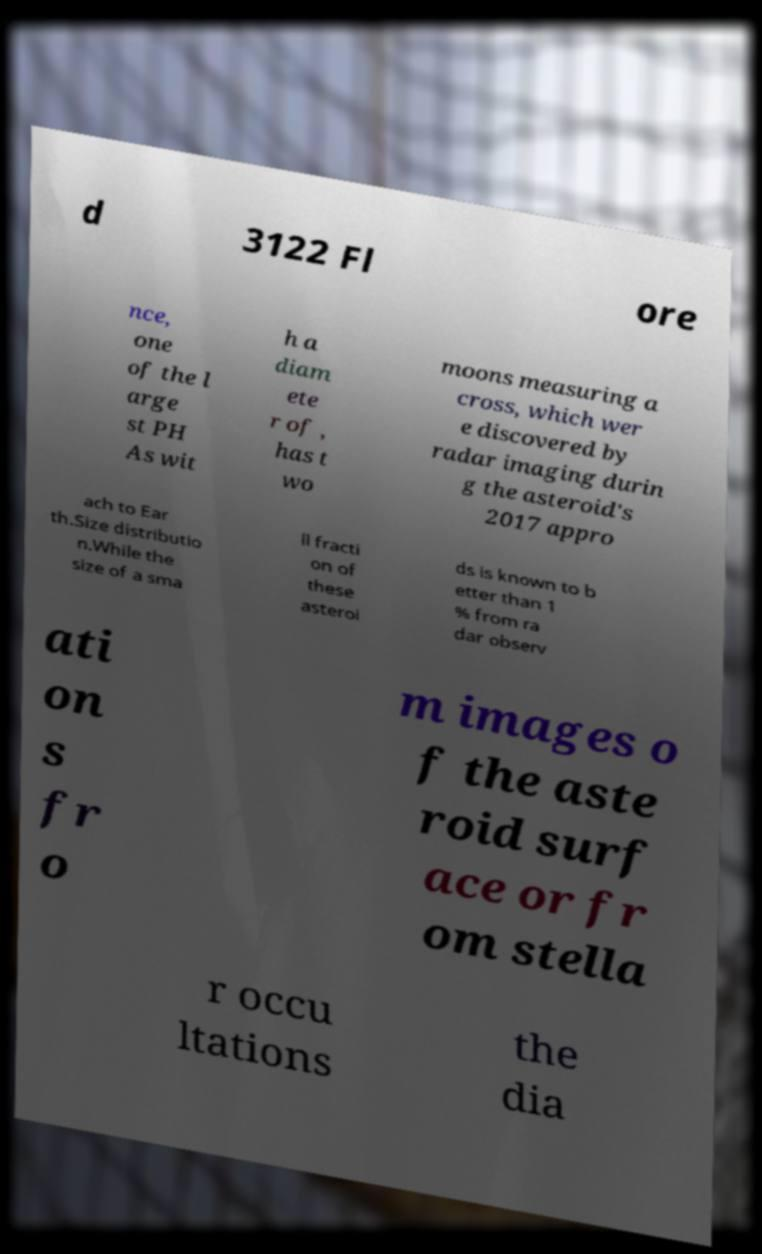Could you assist in decoding the text presented in this image and type it out clearly? d 3122 Fl ore nce, one of the l arge st PH As wit h a diam ete r of , has t wo moons measuring a cross, which wer e discovered by radar imaging durin g the asteroid's 2017 appro ach to Ear th.Size distributio n.While the size of a sma ll fracti on of these asteroi ds is known to b etter than 1 % from ra dar observ ati on s fr o m images o f the aste roid surf ace or fr om stella r occu ltations the dia 